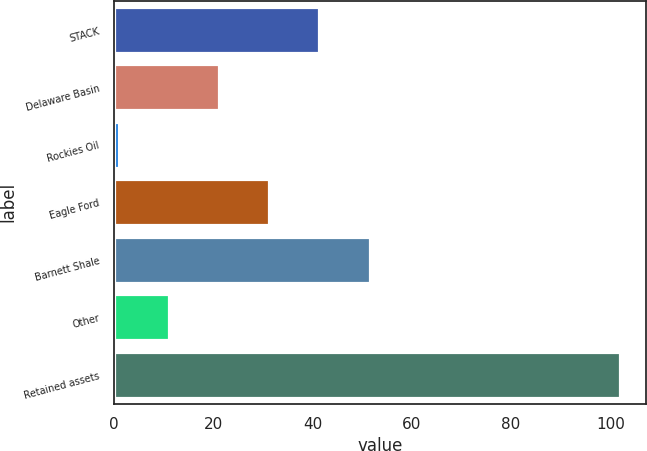Convert chart. <chart><loc_0><loc_0><loc_500><loc_500><bar_chart><fcel>STACK<fcel>Delaware Basin<fcel>Rockies Oil<fcel>Eagle Ford<fcel>Barnett Shale<fcel>Other<fcel>Retained assets<nl><fcel>41.4<fcel>21.2<fcel>1<fcel>31.3<fcel>51.5<fcel>11.1<fcel>102<nl></chart> 